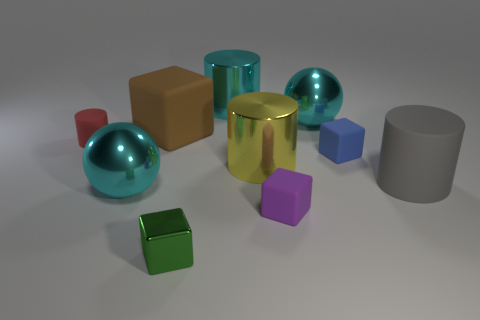Subtract all cubes. How many objects are left? 6 Add 1 gray matte cylinders. How many gray matte cylinders are left? 2 Add 9 gray metallic balls. How many gray metallic balls exist? 9 Subtract 0 green cylinders. How many objects are left? 10 Subtract all big cyan spheres. Subtract all green blocks. How many objects are left? 7 